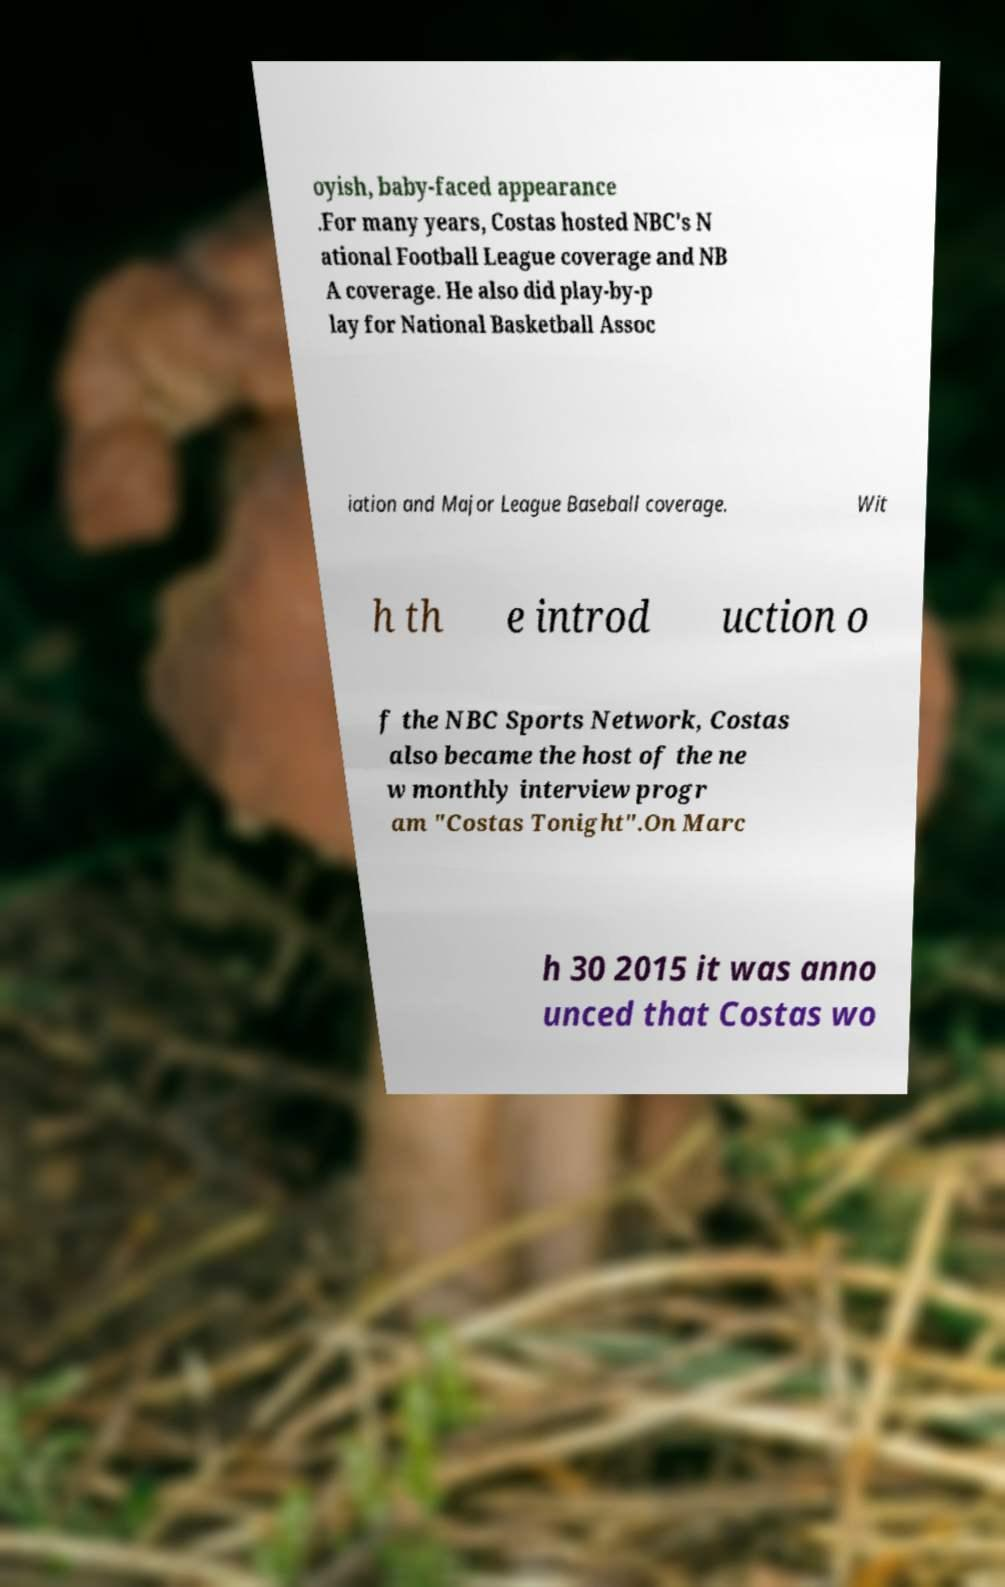Can you accurately transcribe the text from the provided image for me? oyish, baby-faced appearance .For many years, Costas hosted NBC's N ational Football League coverage and NB A coverage. He also did play-by-p lay for National Basketball Assoc iation and Major League Baseball coverage. Wit h th e introd uction o f the NBC Sports Network, Costas also became the host of the ne w monthly interview progr am "Costas Tonight".On Marc h 30 2015 it was anno unced that Costas wo 